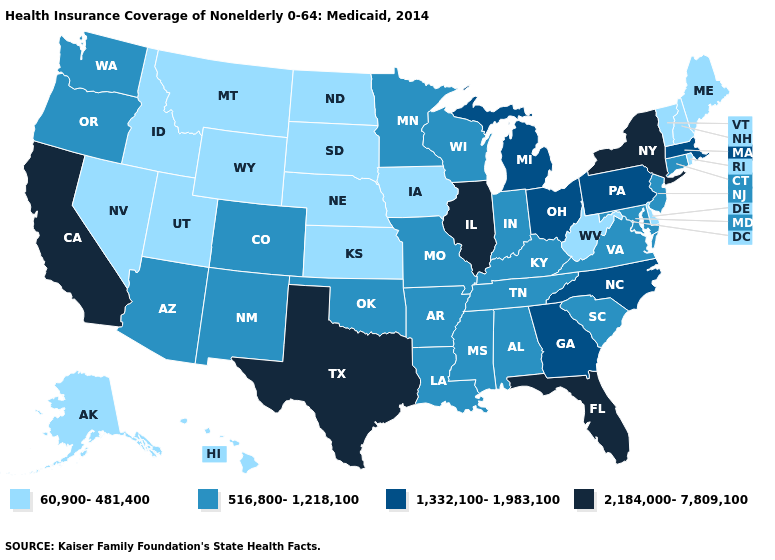Name the states that have a value in the range 1,332,100-1,983,100?
Give a very brief answer. Georgia, Massachusetts, Michigan, North Carolina, Ohio, Pennsylvania. Name the states that have a value in the range 2,184,000-7,809,100?
Be succinct. California, Florida, Illinois, New York, Texas. Is the legend a continuous bar?
Concise answer only. No. What is the value of Indiana?
Concise answer only. 516,800-1,218,100. Which states hav the highest value in the Northeast?
Concise answer only. New York. Name the states that have a value in the range 60,900-481,400?
Be succinct. Alaska, Delaware, Hawaii, Idaho, Iowa, Kansas, Maine, Montana, Nebraska, Nevada, New Hampshire, North Dakota, Rhode Island, South Dakota, Utah, Vermont, West Virginia, Wyoming. Name the states that have a value in the range 1,332,100-1,983,100?
Give a very brief answer. Georgia, Massachusetts, Michigan, North Carolina, Ohio, Pennsylvania. Which states have the lowest value in the MidWest?
Keep it brief. Iowa, Kansas, Nebraska, North Dakota, South Dakota. Among the states that border Kansas , which have the highest value?
Write a very short answer. Colorado, Missouri, Oklahoma. What is the highest value in states that border Virginia?
Be succinct. 1,332,100-1,983,100. What is the highest value in the USA?
Write a very short answer. 2,184,000-7,809,100. What is the highest value in the Northeast ?
Short answer required. 2,184,000-7,809,100. Among the states that border Montana , which have the highest value?
Give a very brief answer. Idaho, North Dakota, South Dakota, Wyoming. How many symbols are there in the legend?
Give a very brief answer. 4. Among the states that border Utah , does Idaho have the lowest value?
Keep it brief. Yes. 